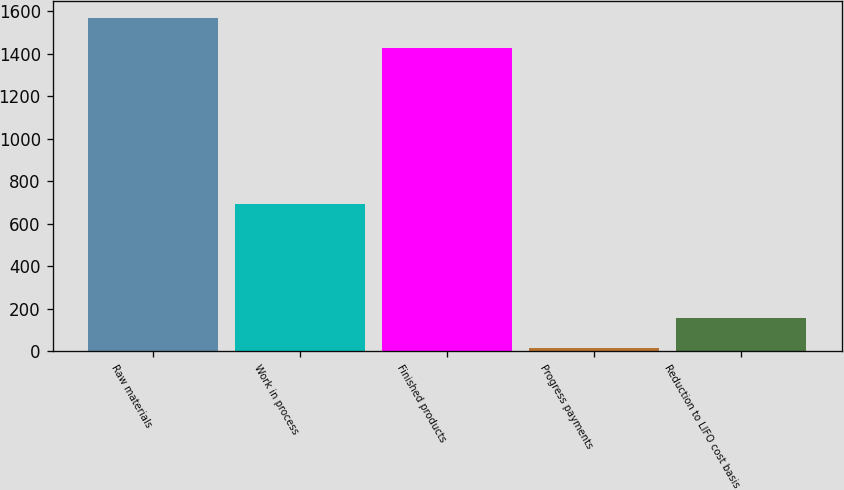<chart> <loc_0><loc_0><loc_500><loc_500><bar_chart><fcel>Raw materials<fcel>Work in process<fcel>Finished products<fcel>Progress payments<fcel>Reduction to LIFO cost basis<nl><fcel>1569.4<fcel>695<fcel>1427<fcel>14<fcel>156.4<nl></chart> 